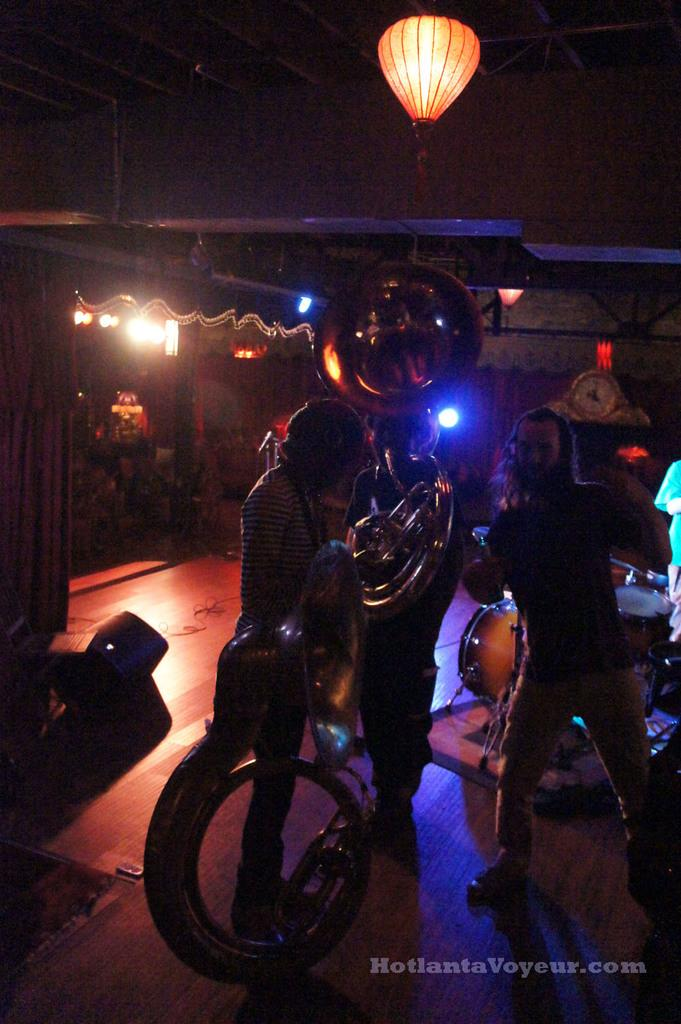What are the people in the image doing? The people in the image are playing musical instruments. What type of structure can be seen in the image? There is a stall in the image. What can be seen illuminating the area in the image? There are lights and a lantern hanging from the roof in the image. What type of disgust can be smelled in the image? There is no mention of any scent, disgusting or otherwise, in the image. 